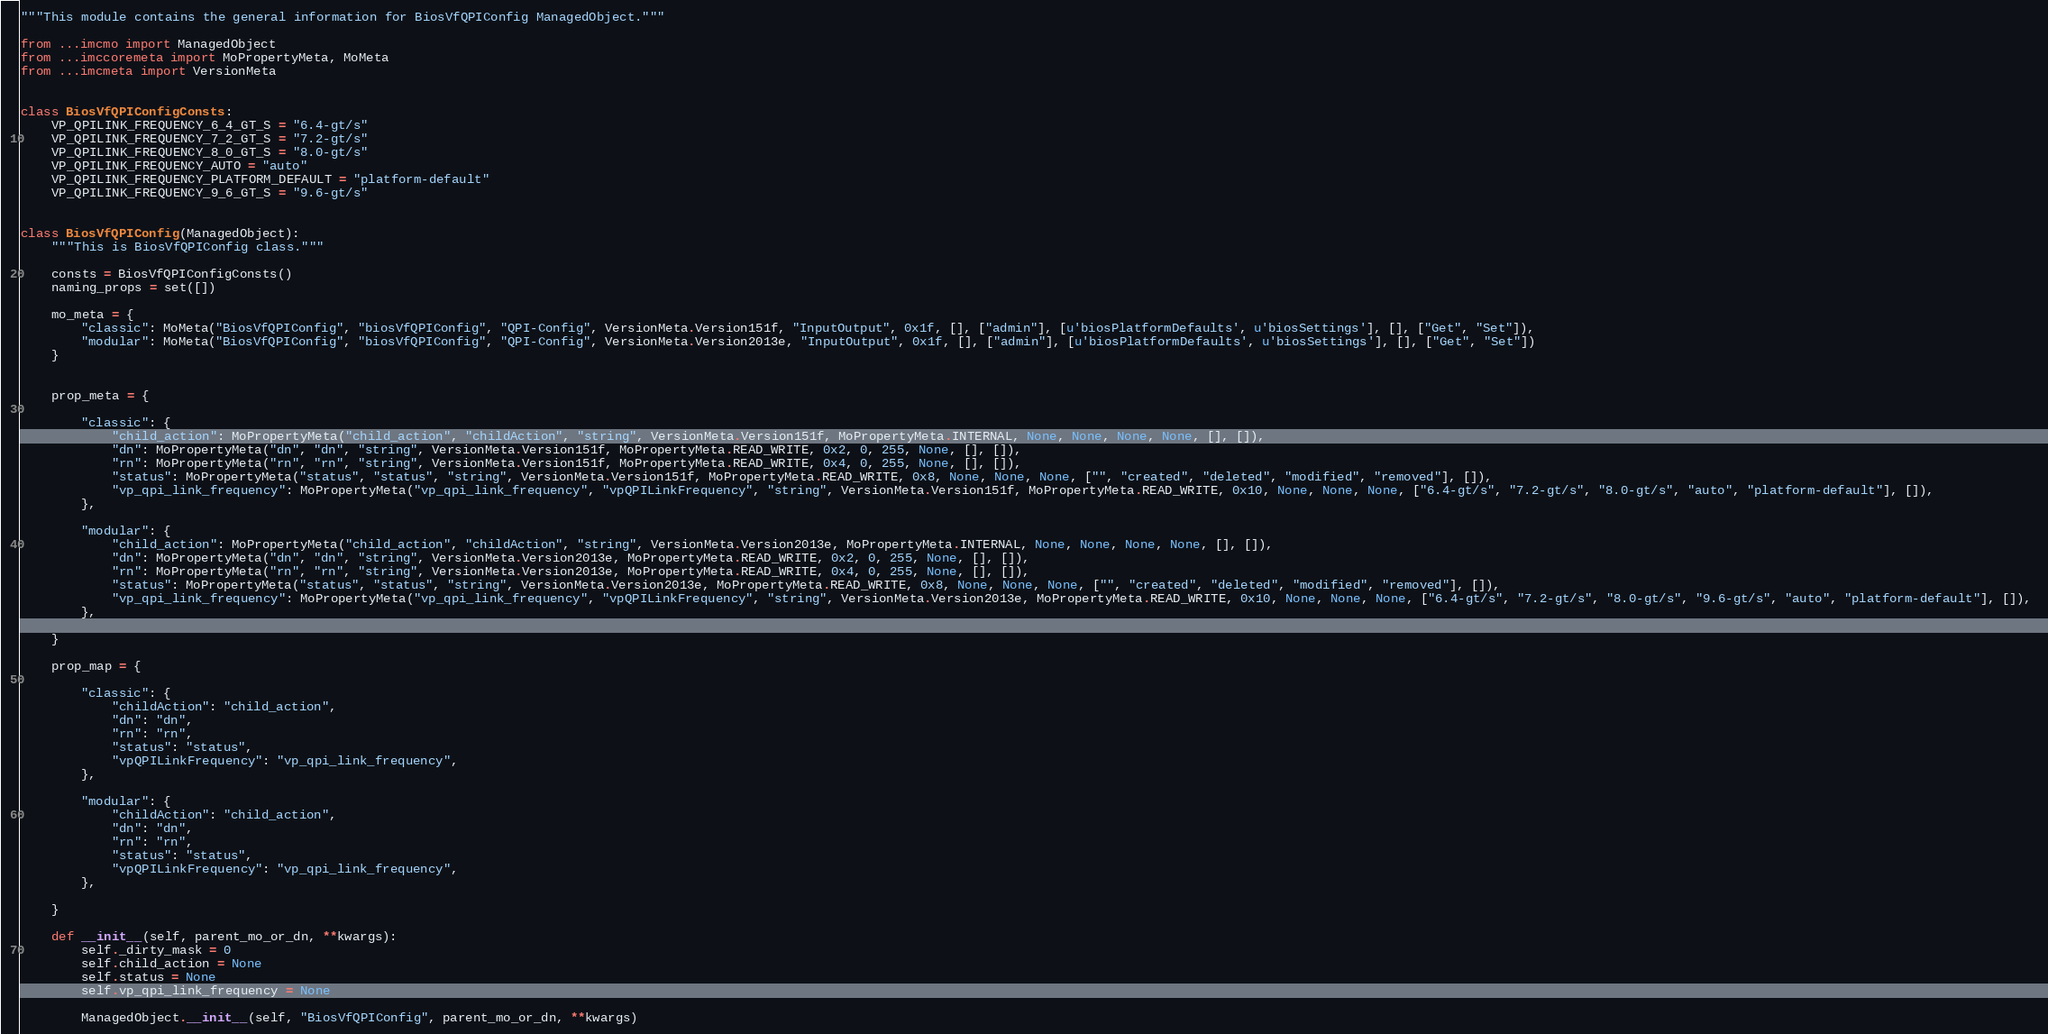Convert code to text. <code><loc_0><loc_0><loc_500><loc_500><_Python_>"""This module contains the general information for BiosVfQPIConfig ManagedObject."""

from ...imcmo import ManagedObject
from ...imccoremeta import MoPropertyMeta, MoMeta
from ...imcmeta import VersionMeta


class BiosVfQPIConfigConsts:
    VP_QPILINK_FREQUENCY_6_4_GT_S = "6.4-gt/s"
    VP_QPILINK_FREQUENCY_7_2_GT_S = "7.2-gt/s"
    VP_QPILINK_FREQUENCY_8_0_GT_S = "8.0-gt/s"
    VP_QPILINK_FREQUENCY_AUTO = "auto"
    VP_QPILINK_FREQUENCY_PLATFORM_DEFAULT = "platform-default"
    VP_QPILINK_FREQUENCY_9_6_GT_S = "9.6-gt/s"


class BiosVfQPIConfig(ManagedObject):
    """This is BiosVfQPIConfig class."""

    consts = BiosVfQPIConfigConsts()
    naming_props = set([])

    mo_meta = {
        "classic": MoMeta("BiosVfQPIConfig", "biosVfQPIConfig", "QPI-Config", VersionMeta.Version151f, "InputOutput", 0x1f, [], ["admin"], [u'biosPlatformDefaults', u'biosSettings'], [], ["Get", "Set"]),
        "modular": MoMeta("BiosVfQPIConfig", "biosVfQPIConfig", "QPI-Config", VersionMeta.Version2013e, "InputOutput", 0x1f, [], ["admin"], [u'biosPlatformDefaults', u'biosSettings'], [], ["Get", "Set"])
    }


    prop_meta = {

        "classic": {
            "child_action": MoPropertyMeta("child_action", "childAction", "string", VersionMeta.Version151f, MoPropertyMeta.INTERNAL, None, None, None, None, [], []), 
            "dn": MoPropertyMeta("dn", "dn", "string", VersionMeta.Version151f, MoPropertyMeta.READ_WRITE, 0x2, 0, 255, None, [], []), 
            "rn": MoPropertyMeta("rn", "rn", "string", VersionMeta.Version151f, MoPropertyMeta.READ_WRITE, 0x4, 0, 255, None, [], []), 
            "status": MoPropertyMeta("status", "status", "string", VersionMeta.Version151f, MoPropertyMeta.READ_WRITE, 0x8, None, None, None, ["", "created", "deleted", "modified", "removed"], []), 
            "vp_qpi_link_frequency": MoPropertyMeta("vp_qpi_link_frequency", "vpQPILinkFrequency", "string", VersionMeta.Version151f, MoPropertyMeta.READ_WRITE, 0x10, None, None, None, ["6.4-gt/s", "7.2-gt/s", "8.0-gt/s", "auto", "platform-default"], []), 
        },

        "modular": {
            "child_action": MoPropertyMeta("child_action", "childAction", "string", VersionMeta.Version2013e, MoPropertyMeta.INTERNAL, None, None, None, None, [], []), 
            "dn": MoPropertyMeta("dn", "dn", "string", VersionMeta.Version2013e, MoPropertyMeta.READ_WRITE, 0x2, 0, 255, None, [], []), 
            "rn": MoPropertyMeta("rn", "rn", "string", VersionMeta.Version2013e, MoPropertyMeta.READ_WRITE, 0x4, 0, 255, None, [], []), 
            "status": MoPropertyMeta("status", "status", "string", VersionMeta.Version2013e, MoPropertyMeta.READ_WRITE, 0x8, None, None, None, ["", "created", "deleted", "modified", "removed"], []), 
            "vp_qpi_link_frequency": MoPropertyMeta("vp_qpi_link_frequency", "vpQPILinkFrequency", "string", VersionMeta.Version2013e, MoPropertyMeta.READ_WRITE, 0x10, None, None, None, ["6.4-gt/s", "7.2-gt/s", "8.0-gt/s", "9.6-gt/s", "auto", "platform-default"], []), 
        },

    }

    prop_map = {

        "classic": {
            "childAction": "child_action", 
            "dn": "dn", 
            "rn": "rn", 
            "status": "status", 
            "vpQPILinkFrequency": "vp_qpi_link_frequency", 
        },

        "modular": {
            "childAction": "child_action", 
            "dn": "dn", 
            "rn": "rn", 
            "status": "status", 
            "vpQPILinkFrequency": "vp_qpi_link_frequency", 
        },

    }

    def __init__(self, parent_mo_or_dn, **kwargs):
        self._dirty_mask = 0
        self.child_action = None
        self.status = None
        self.vp_qpi_link_frequency = None

        ManagedObject.__init__(self, "BiosVfQPIConfig", parent_mo_or_dn, **kwargs)

</code> 